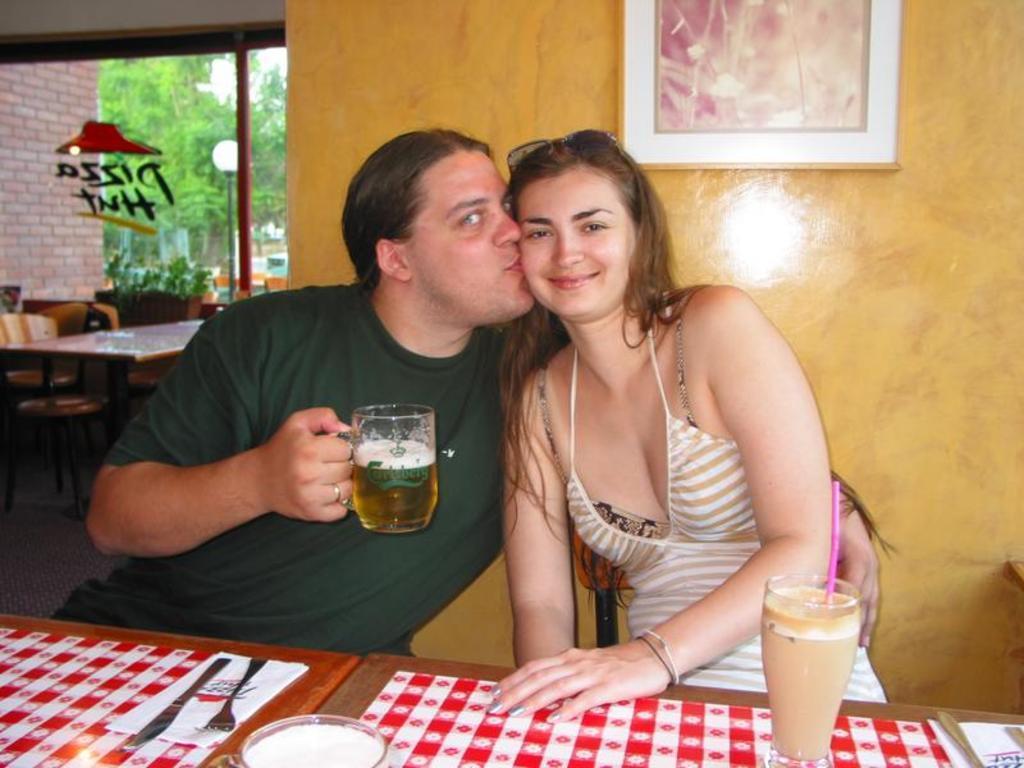Please provide a concise description of this image. In this image there are two persons, one person sitting and smiling and other person is sitting and holding the glass. There is a glass, spoon, fork, knife, tissues on the table and at the back there is a painting on the wall and at the back there are table, chairs and there is a tree. 